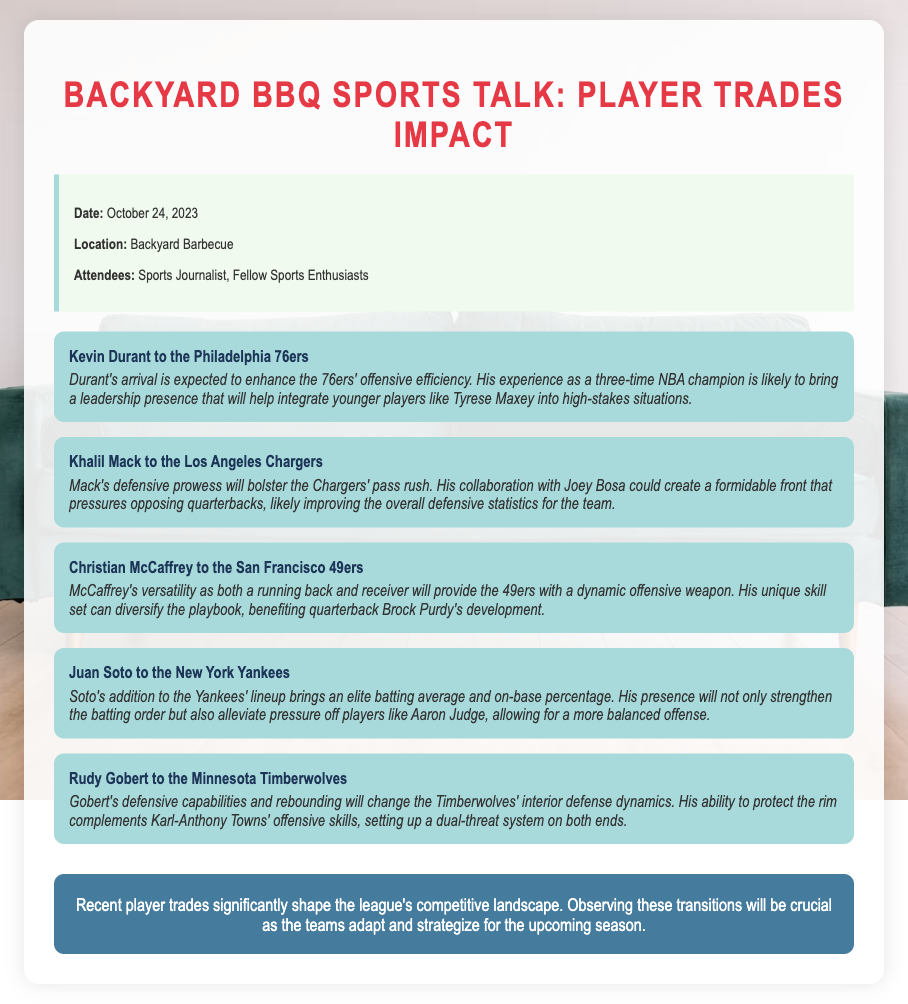What is the date of the meeting? The meeting date is prominently stated in the document as October 24, 2023.
Answer: October 24, 2023 Who was traded to the Philadelphia 76ers? The document specifies that Kevin Durant was traded to the Philadelphia 76ers.
Answer: Kevin Durant What position is Christian McCaffrey known for? The document indicates that McCaffrey is known for being both a running back and receiver, highlighting his versatility.
Answer: Running back and receiver Which player's arrival is expected to enhance the 76ers' offensive efficiency? The text mentions that Kevin Durant's arrival is expected to enhance the 76ers' offensive efficiency.
Answer: Kevin Durant What team did Juan Soto join? Juan Soto is indicated to have joined the New York Yankees in the document.
Answer: New York Yankees How will Khalil Mack's trade impact the Chargers' defensive statistics? The document states that Mack's collaboration with Bosa could improve the overall defensive statistics for the Chargers.
Answer: Improve defensive statistics What aspect of Rudy Gobert's game will benefit the Timberwolves? The document highlights that Gobert's defensive capabilities and rebounding will benefit the Timberwolves' interior defense dynamics.
Answer: Defensive capabilities and rebounding What is the purpose of this meeting's discussion? The purpose is to overview recent player trades and their potential impact on team dynamics for the upcoming season.
Answer: To overview recent player trades Who attended the meeting? The document specifies the attendees as a Sports Journalist and Fellow Sports Enthusiasts.
Answer: Sports Journalist, Fellow Sports Enthusiasts 